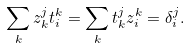Convert formula to latex. <formula><loc_0><loc_0><loc_500><loc_500>\sum _ { k } z ^ { j } _ { k } t ^ { k } _ { i } = \sum _ { k } t ^ { j } _ { k } z ^ { k } _ { i } = \delta _ { i } ^ { j } .</formula> 